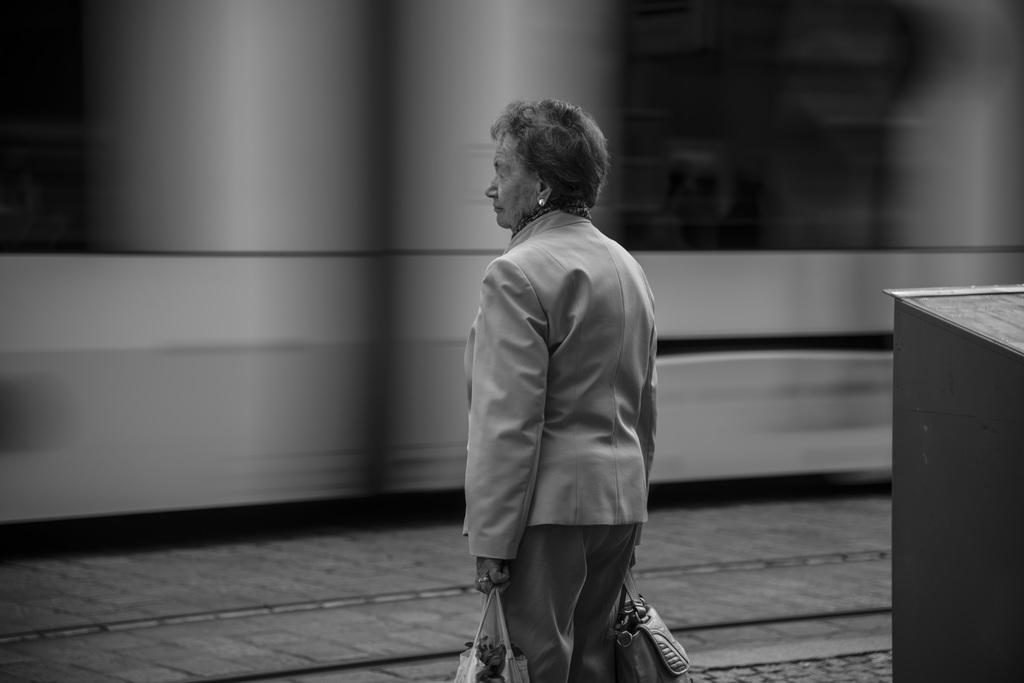Who is present in the image? There is a woman in the image. What is the woman doing in the image? The woman is standing in the image. What is the woman holding in the image? The woman is holding bags in the image. Can you see a basketball being played in the image? There is no basketball or any indication of a game being played in the image. 